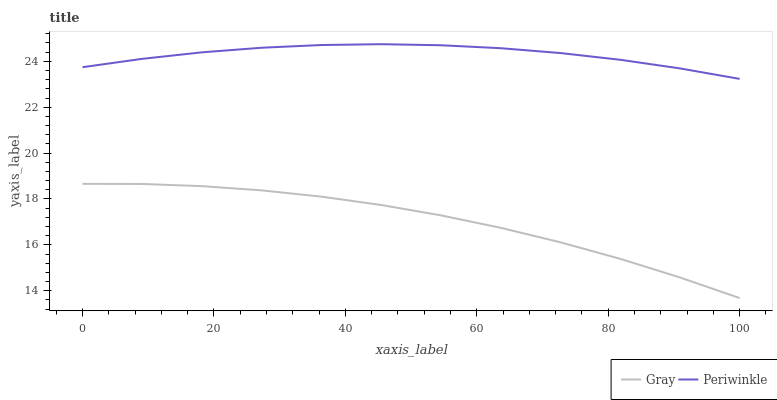Does Gray have the minimum area under the curve?
Answer yes or no. Yes. Does Periwinkle have the maximum area under the curve?
Answer yes or no. Yes. Does Periwinkle have the minimum area under the curve?
Answer yes or no. No. Is Periwinkle the smoothest?
Answer yes or no. Yes. Is Gray the roughest?
Answer yes or no. Yes. Is Periwinkle the roughest?
Answer yes or no. No. Does Periwinkle have the lowest value?
Answer yes or no. No. Does Periwinkle have the highest value?
Answer yes or no. Yes. Is Gray less than Periwinkle?
Answer yes or no. Yes. Is Periwinkle greater than Gray?
Answer yes or no. Yes. Does Gray intersect Periwinkle?
Answer yes or no. No. 